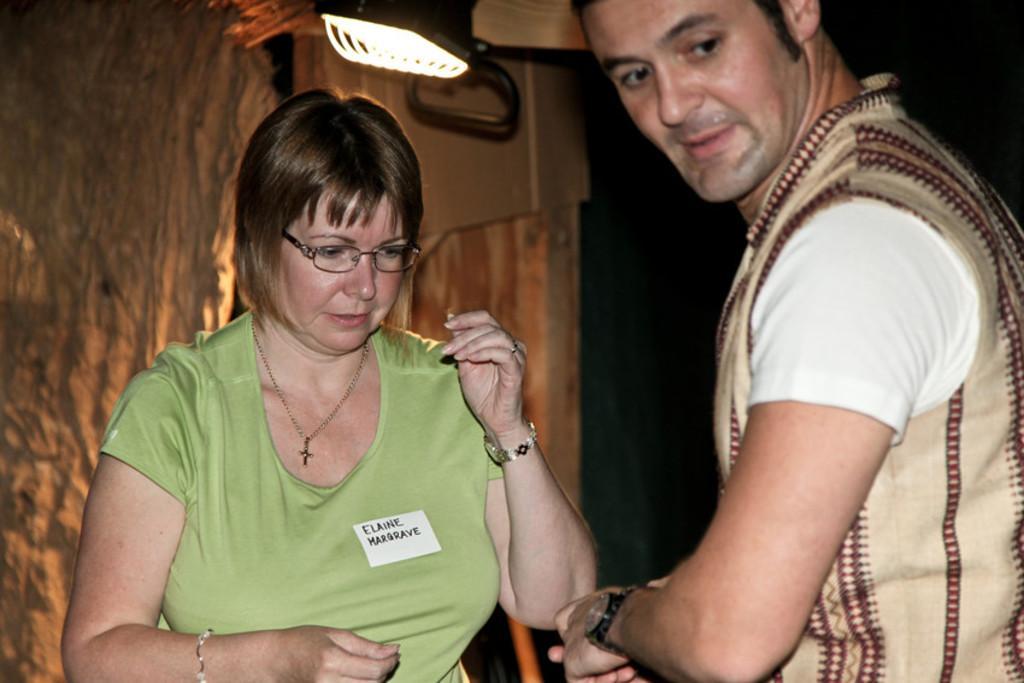Can you describe this image briefly? In the image we can see a man and a woman standing, they are wearing clothes. This is a wrist watch, bracelet, neck chain, finger ring and spectacles. This is a light. 